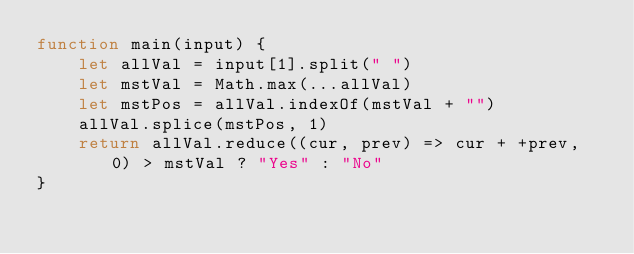<code> <loc_0><loc_0><loc_500><loc_500><_JavaScript_>function main(input) {
    let allVal = input[1].split(" ")
    let mstVal = Math.max(...allVal)
    let mstPos = allVal.indexOf(mstVal + "")
    allVal.splice(mstPos, 1)
    return allVal.reduce((cur, prev) => cur + +prev, 0) > mstVal ? "Yes" : "No"
}</code> 